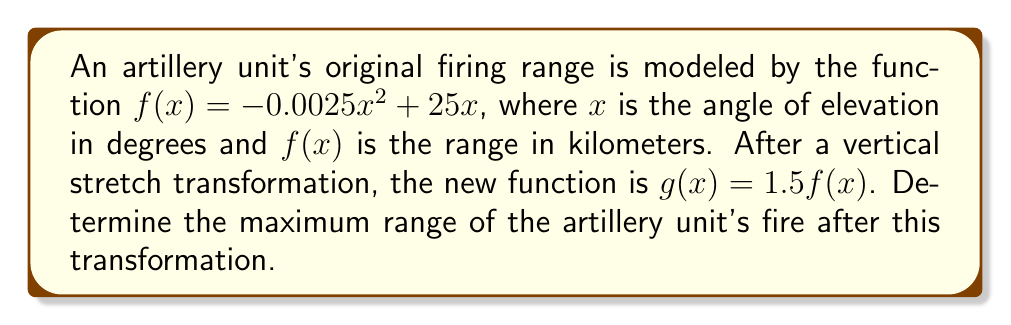Help me with this question. 1) The original function is $f(x) = -0.0025x^2 + 25x$

2) After the vertical stretch, we have $g(x) = 1.5f(x) = 1.5(-0.0025x^2 + 25x)$

3) Simplify: $g(x) = -0.00375x^2 + 37.5x$

4) To find the maximum range, we need to find the vertex of this parabola. The x-coordinate of the vertex is given by $x = -\frac{b}{2a}$, where $a$ and $b$ are the coefficients of $x^2$ and $x$ respectively.

5) $x = -\frac{37.5}{2(-0.00375)} = 5000$

6) To find the maximum range, substitute this x-value back into $g(x)$:

   $g(5000) = -0.00375(5000)^2 + 37.5(5000)$
   $= -93750 + 187500$
   $= 93750$

7) Therefore, the maximum range is 93.75 km.
Answer: 93.75 km 